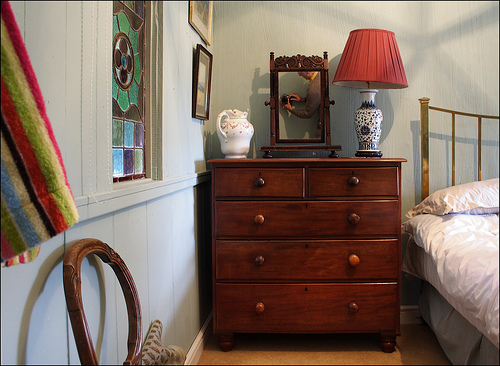<image>
Is the lamp on the table? Yes. Looking at the image, I can see the lamp is positioned on top of the table, with the table providing support. Is the light behind the bed? No. The light is not behind the bed. From this viewpoint, the light appears to be positioned elsewhere in the scene. 